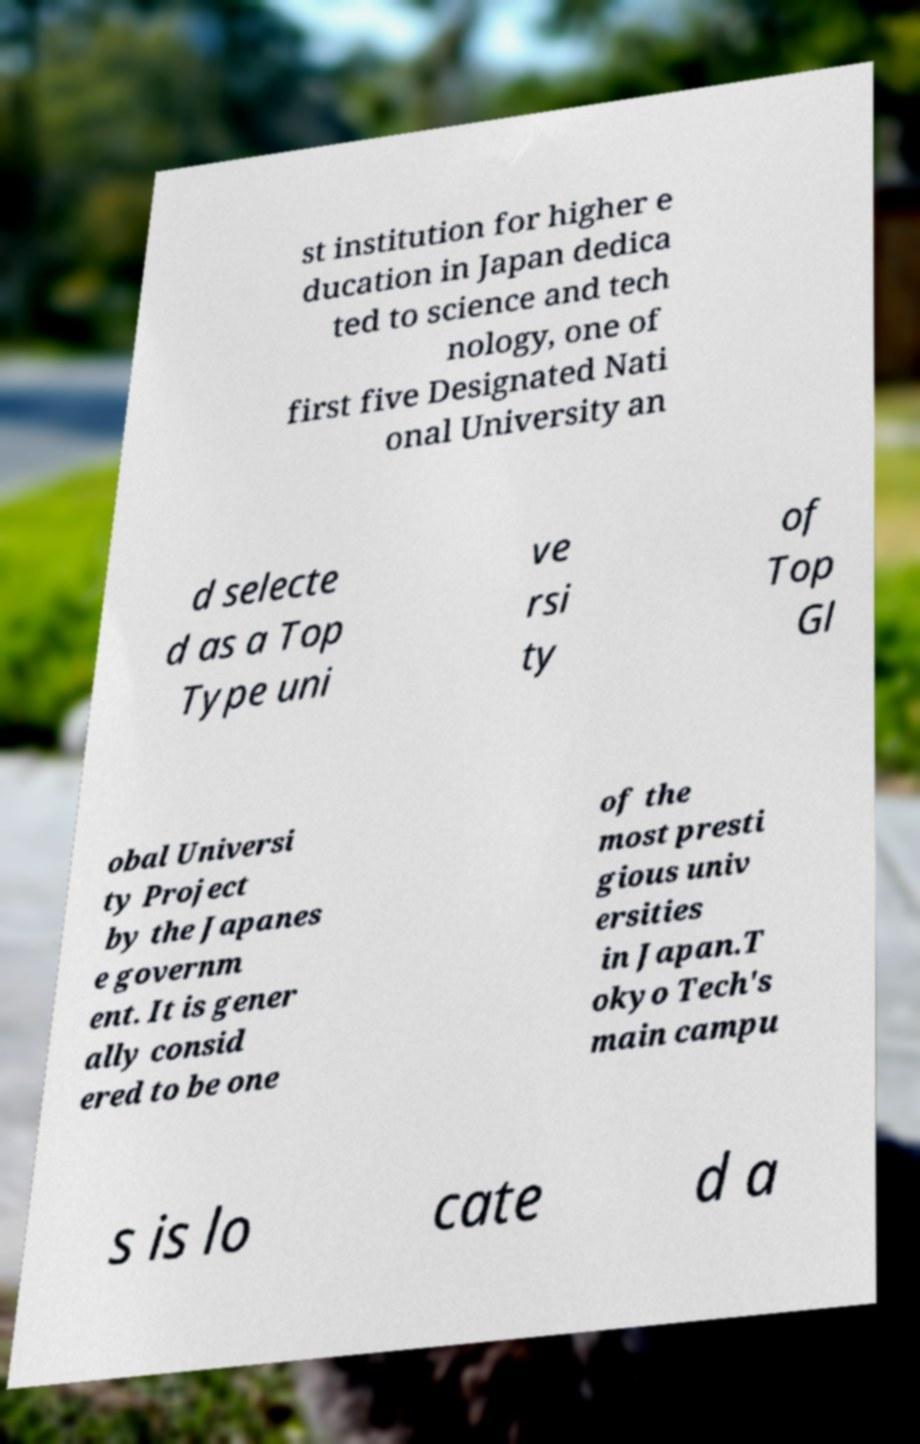I need the written content from this picture converted into text. Can you do that? st institution for higher e ducation in Japan dedica ted to science and tech nology, one of first five Designated Nati onal University an d selecte d as a Top Type uni ve rsi ty of Top Gl obal Universi ty Project by the Japanes e governm ent. It is gener ally consid ered to be one of the most presti gious univ ersities in Japan.T okyo Tech's main campu s is lo cate d a 